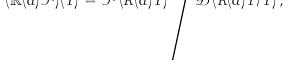<formula> <loc_0><loc_0><loc_500><loc_500>( \mathbb { R } ( d ) \mathcal { F } ) ( T ) = \mathcal { F } \left ( R ( d ) T \right ) \Big / \mathcal { D } \left ( R ( d ) T / T \right ) ,</formula> 